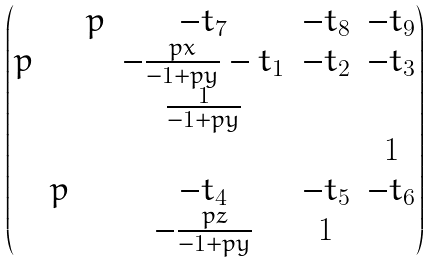<formula> <loc_0><loc_0><loc_500><loc_500>\begin{pmatrix} & & p & - t _ { 7 } & - t _ { 8 } & - t _ { 9 } \\ p & & & - \frac { p x } { - 1 + p y } - t _ { 1 } & - t _ { 2 } & - t _ { 3 } \\ & & & \frac { 1 } { - 1 + p y } & \\ & & & & & 1 \\ & p & & - t _ { 4 } & - t _ { 5 } & - t _ { 6 } \\ & & & - \frac { p z } { - 1 + p y } & 1 \end{pmatrix}</formula> 